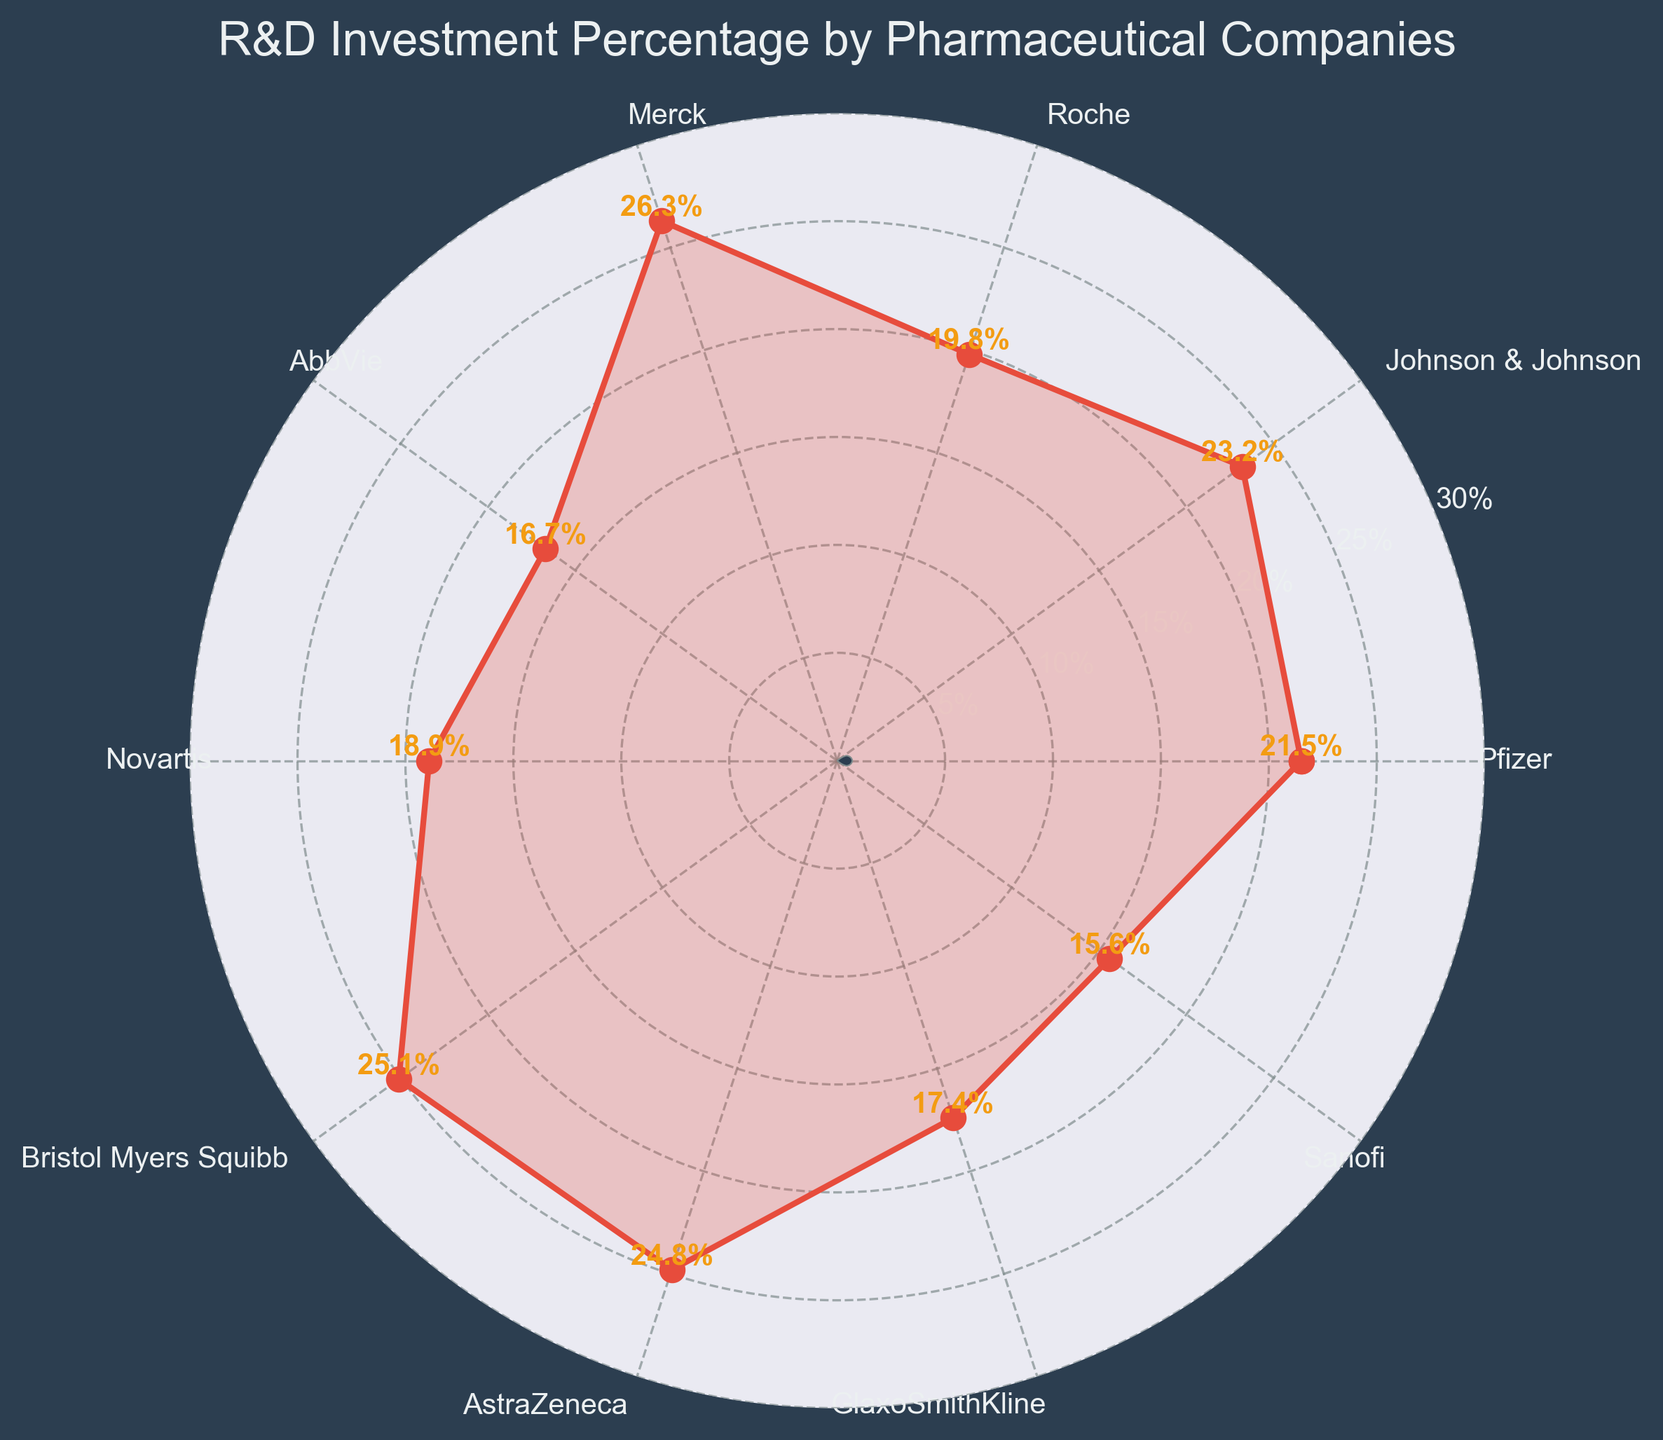What's the title of the figure? The title is located at the top of the figure and helps in identifying the main focus of the plot.
Answer: R&D Investment Percentage by Pharmaceutical Companies Which company has the highest percentage of revenue invested in R&D? By inspecting the labels and the percentages on the figure, we notice that Merck is the highest with 26.3%.
Answer: Merck How many companies have an R&D percentage above 20%? Looking at the plotted data, we count the companies with percentages greater than 20%: Pfizer, Johnson & Johnson, Merck, Bristol Myers Squibb, and AstraZeneca. This makes 5 companies.
Answer: 5 What is the range of the R&D percentages on the plot? To find the range, identify the minimum and maximum values. The minimum is Sanofi with 15.6% and the maximum is Merck with 26.3%. The range is 26.3% - 15.6% = 10.7%.
Answer: 10.7% Which company has the closest R&D percentage to Pfizer? By comparing the percentages, we notice AstraZeneca is very close to Pfizer with 24.8%, while Pfizer has 21.5%. The difference is smaller compared to other companies.
Answer: AstraZeneca Is the R&D percentage of Roche higher or lower than the average R&D percentage of the listed companies? First, calculate the average percentage: (21.5 + 23.2 + 19.8 + 26.3 + 16.7 + 18.9 + 25.1 + 24.8 + 17.4 + 15.6) / 10 = 20.93%. Compare this to Roche's 19.8%. Since 19.8% < 20.93%, Roche's R&D percentage is lower.
Answer: Lower Which companies are within ±2% of the average R&D percentage? The average R&D percentage is 20.93%. Within ±2%, the range is 18.93% to 22.93%. The companies that fall within this range are Pfizer (21.5%) and Novartis (18.9%).
Answer: Pfizer, Novartis How does the R&D percentage of GlaxoSmithKline compare to Johnson & Johnson? Compare the two percentages directly: GlaxoSmithKline has 17.4% while Johnson & Johnson has 23.2%. Therefore, GlaxoSmithKline is lower.
Answer: Lower What is the difference in R&D percentage between the company with the highest and lowest values? Merck has the highest at 26.3%, and Sanofi has the lowest at 15.6%. The difference is 26.3% - 15.6% = 10.7%.
Answer: 10.7% How many companies are at or below the overall average R&D percentage? With an average of 20.93%, the companies at or below this are Roche, AbbVie, Novartis, GlaxoSmithKline, and Sanofi, totaling 5 companies.
Answer: 5 